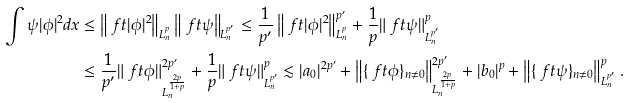Convert formula to latex. <formula><loc_0><loc_0><loc_500><loc_500>\int \psi | \phi | ^ { 2 } d x & \leq \left \| \ f t { | \phi | ^ { 2 } } \right \| _ { L _ { n } ^ { p } } \left \| \ f t { \psi } \right \| _ { L _ { n } ^ { p ^ { \prime } } } \leq \frac { 1 } { p ^ { \prime } } \left \| \ f t { | \phi | ^ { 2 } } \right \| ^ { p ^ { \prime } } _ { L _ { n } ^ { p } } + \frac { 1 } { p } \| \ f t { \psi } \| ^ { p } _ { L _ { n } ^ { p ^ { \prime } } } \\ & \leq \frac { 1 } { p ^ { \prime } } \| \ f t { \phi } \| ^ { 2 p ^ { \prime } } _ { L _ { n } ^ { \frac { 2 p } { 1 + p } } } + \frac { 1 } { p } \| \ f t { \psi } \| ^ { p } _ { L _ { n } ^ { p ^ { \prime } } } \lesssim | a _ { 0 } | ^ { 2 p ^ { \prime } } + \left \| \{ \ f t { \phi } \} _ { n \ne 0 } \right \| ^ { 2 p ^ { \prime } } _ { L _ { n } ^ { \frac { 2 p } { 1 + p } } } + | b _ { 0 } | ^ { p } + \left \| \{ \ f t { \psi } \} _ { n \ne 0 } \right \| ^ { p } _ { L _ { n } ^ { p ^ { \prime } } } .</formula> 